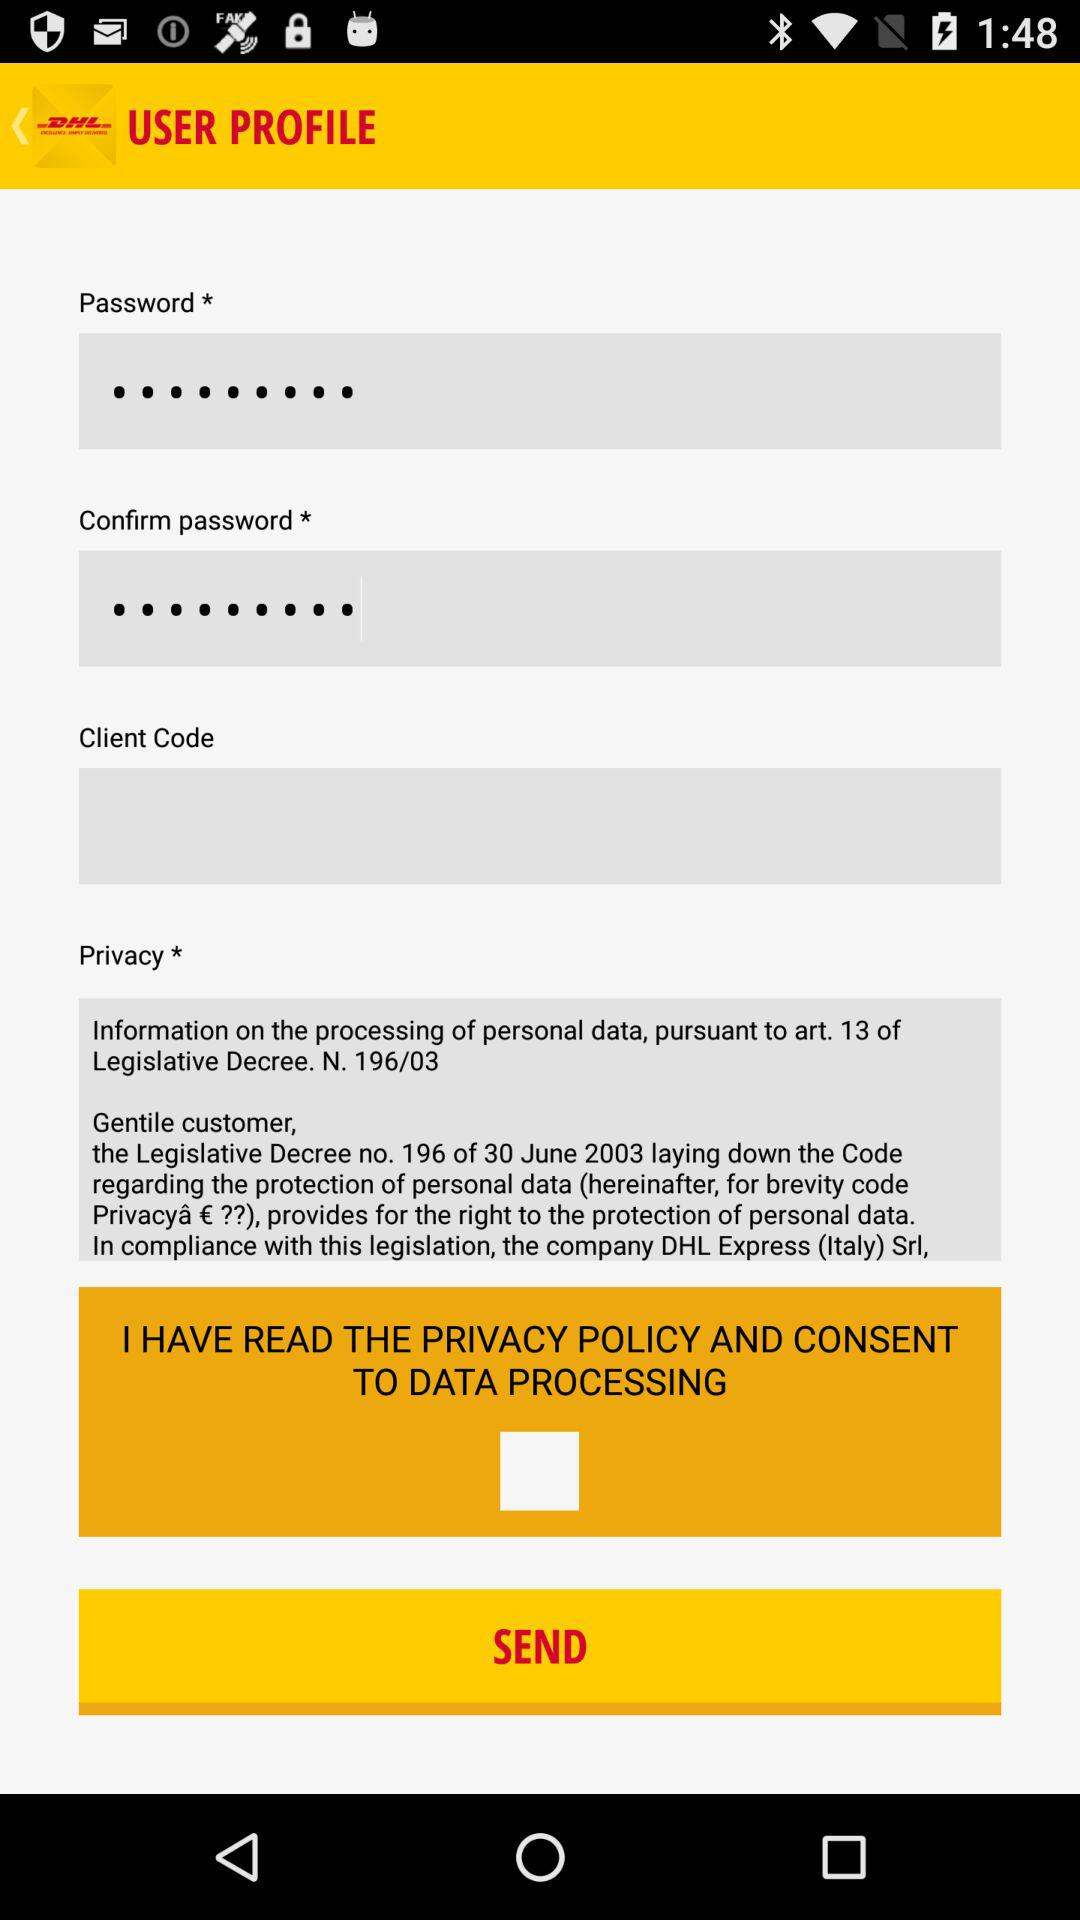What is the application name? The application name is "DHL". 